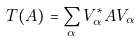Convert formula to latex. <formula><loc_0><loc_0><loc_500><loc_500>T ( A ) = \sum _ { \alpha } V ^ { * } _ { \alpha } A V _ { \alpha }</formula> 